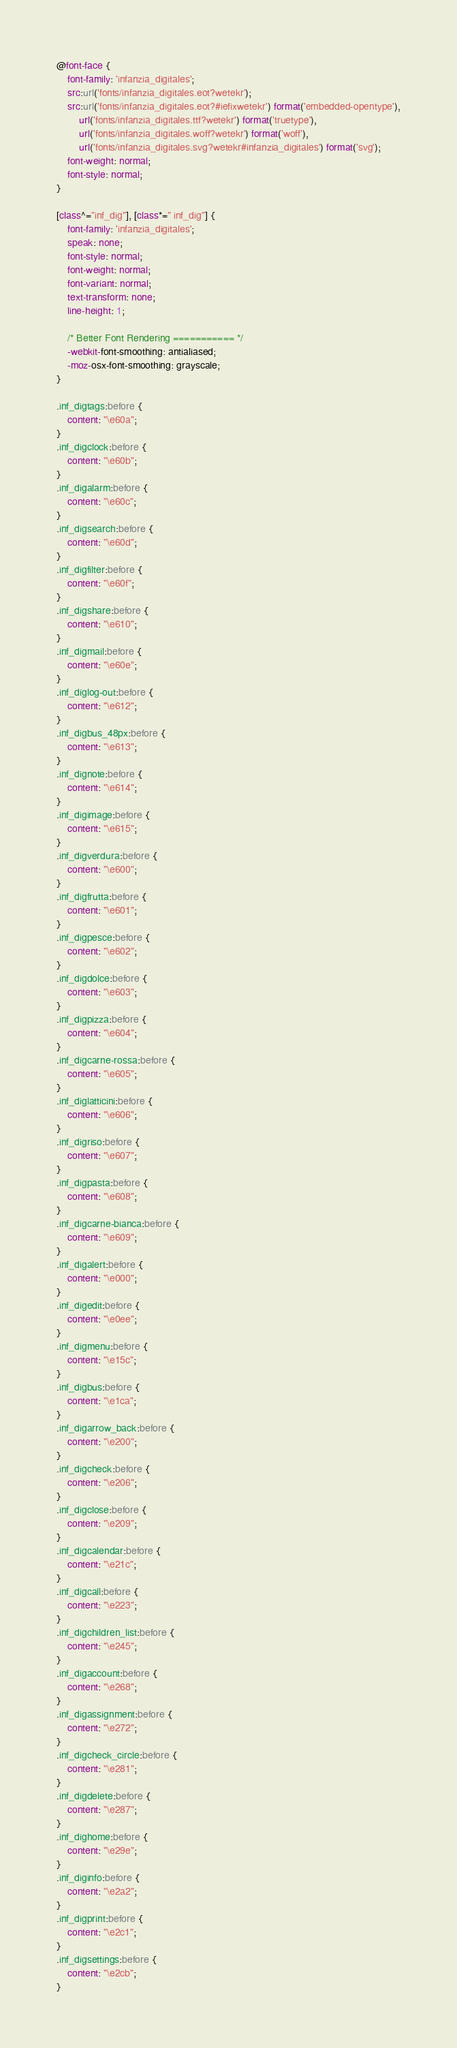Convert code to text. <code><loc_0><loc_0><loc_500><loc_500><_CSS_>@font-face {
	font-family: 'infanzia_digitales';
	src:url('fonts/infanzia_digitales.eot?wetekr');
	src:url('fonts/infanzia_digitales.eot?#iefixwetekr') format('embedded-opentype'),
		url('fonts/infanzia_digitales.ttf?wetekr') format('truetype'),
		url('fonts/infanzia_digitales.woff?wetekr') format('woff'),
		url('fonts/infanzia_digitales.svg?wetekr#infanzia_digitales') format('svg');
	font-weight: normal;
	font-style: normal;
}

[class^="inf_dig"], [class*=" inf_dig"] {
	font-family: 'infanzia_digitales';
	speak: none;
	font-style: normal;
	font-weight: normal;
	font-variant: normal;
	text-transform: none;
	line-height: 1;

	/* Better Font Rendering =========== */
	-webkit-font-smoothing: antialiased;
	-moz-osx-font-smoothing: grayscale;
}

.inf_digtags:before {
	content: "\e60a";
}
.inf_digclock:before {
	content: "\e60b";
}
.inf_digalarm:before {
	content: "\e60c";
}
.inf_digsearch:before {
	content: "\e60d";
}
.inf_digfilter:before {
	content: "\e60f";
}
.inf_digshare:before {
	content: "\e610";
}
.inf_digmail:before {
	content: "\e60e";
}
.inf_diglog-out:before {
	content: "\e612";
}
.inf_digbus_48px:before {
	content: "\e613";
}
.inf_dignote:before {
	content: "\e614";
}
.inf_digimage:before {
	content: "\e615";
}
.inf_digverdura:before {
	content: "\e600";
}
.inf_digfrutta:before {
	content: "\e601";
}
.inf_digpesce:before {
	content: "\e602";
}
.inf_digdolce:before {
	content: "\e603";
}
.inf_digpizza:before {
	content: "\e604";
}
.inf_digcarne-rossa:before {
	content: "\e605";
}
.inf_diglatticini:before {
	content: "\e606";
}
.inf_digriso:before {
	content: "\e607";
}
.inf_digpasta:before {
	content: "\e608";
}
.inf_digcarne-bianca:before {
	content: "\e609";
}
.inf_digalert:before {
	content: "\e000";
}
.inf_digedit:before {
	content: "\e0ee";
}
.inf_digmenu:before {
	content: "\e15c";
}
.inf_digbus:before {
	content: "\e1ca";
}
.inf_digarrow_back:before {
	content: "\e200";
}
.inf_digcheck:before {
	content: "\e206";
}
.inf_digclose:before {
	content: "\e209";
}
.inf_digcalendar:before {
	content: "\e21c";
}
.inf_digcall:before {
	content: "\e223";
}
.inf_digchildren_list:before {
	content: "\e245";
}
.inf_digaccount:before {
	content: "\e268";
}
.inf_digassignment:before {
	content: "\e272";
}
.inf_digcheck_circle:before {
	content: "\e281";
}
.inf_digdelete:before {
	content: "\e287";
}
.inf_dighome:before {
	content: "\e29e";
}
.inf_diginfo:before {
	content: "\e2a2";
}
.inf_digprint:before {
	content: "\e2c1";
}
.inf_digsettings:before {
	content: "\e2cb";
}
</code> 